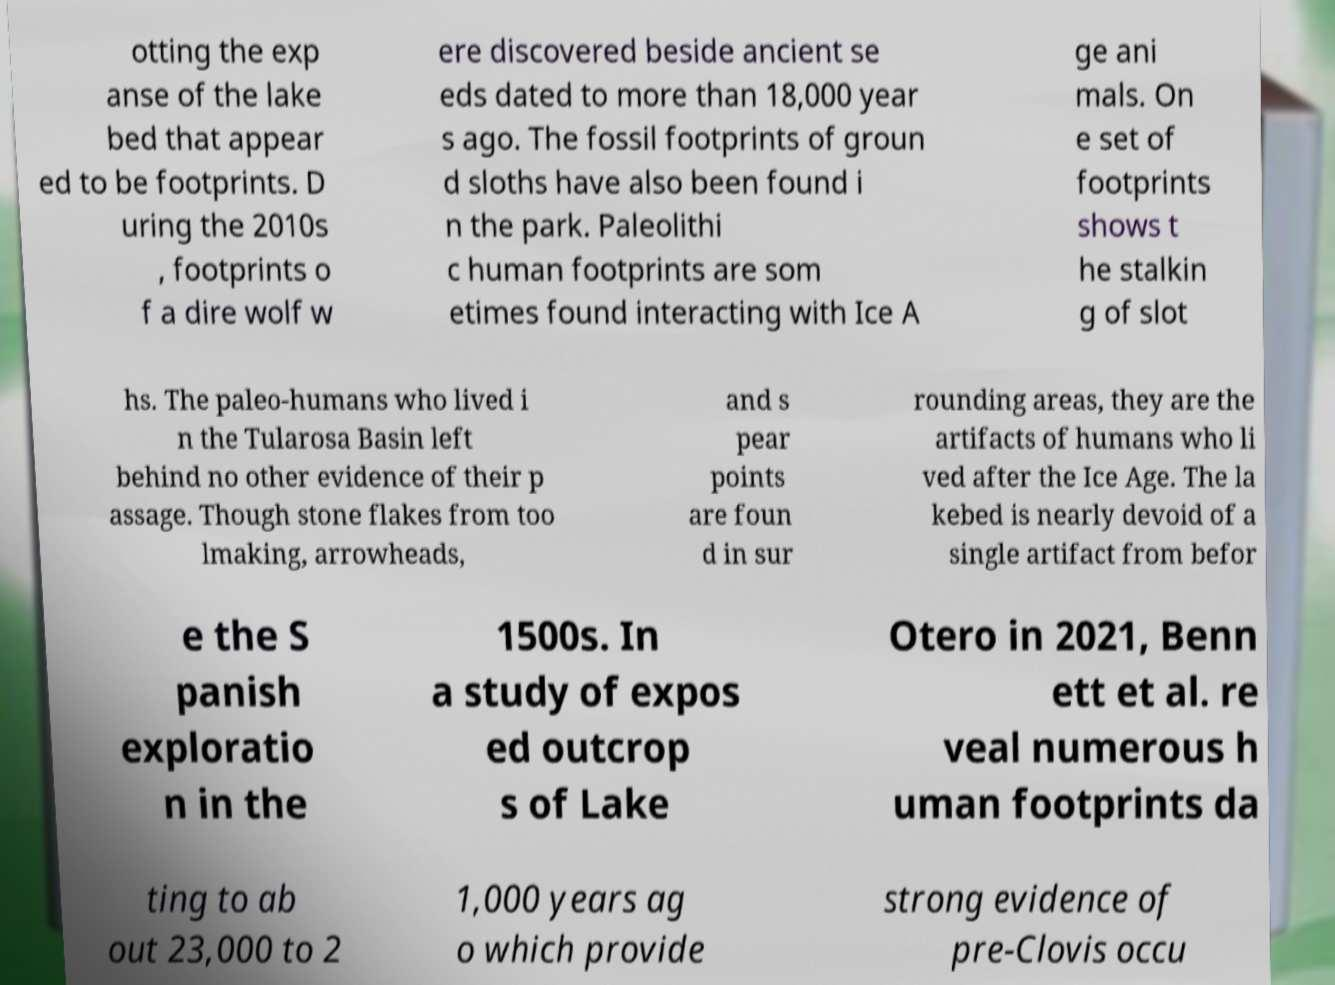Can you accurately transcribe the text from the provided image for me? otting the exp anse of the lake bed that appear ed to be footprints. D uring the 2010s , footprints o f a dire wolf w ere discovered beside ancient se eds dated to more than 18,000 year s ago. The fossil footprints of groun d sloths have also been found i n the park. Paleolithi c human footprints are som etimes found interacting with Ice A ge ani mals. On e set of footprints shows t he stalkin g of slot hs. The paleo-humans who lived i n the Tularosa Basin left behind no other evidence of their p assage. Though stone flakes from too lmaking, arrowheads, and s pear points are foun d in sur rounding areas, they are the artifacts of humans who li ved after the Ice Age. The la kebed is nearly devoid of a single artifact from befor e the S panish exploratio n in the 1500s. In a study of expos ed outcrop s of Lake Otero in 2021, Benn ett et al. re veal numerous h uman footprints da ting to ab out 23,000 to 2 1,000 years ag o which provide strong evidence of pre-Clovis occu 